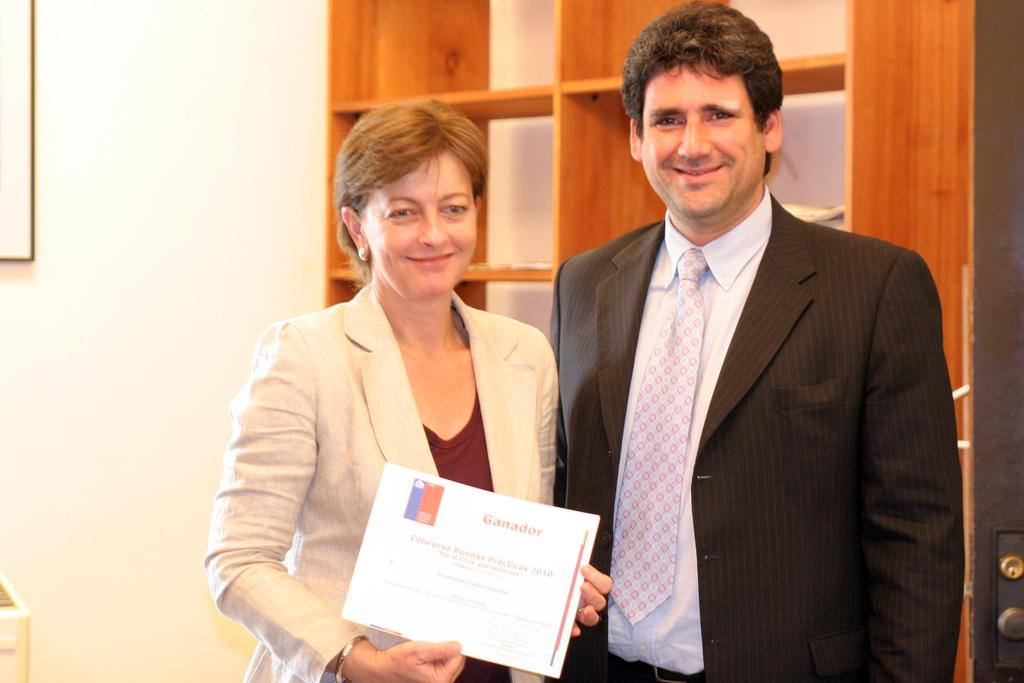Who are the people in the image? There is a man and a woman in the image. What are the man and woman holding in the image? They are holding paper. Where are the man and woman standing in the image? They are standing on the ground. What can be seen in the background of the image? There are shelves and a wall in the background of the image. How many horses are present in the image? There are no horses present in the image. 